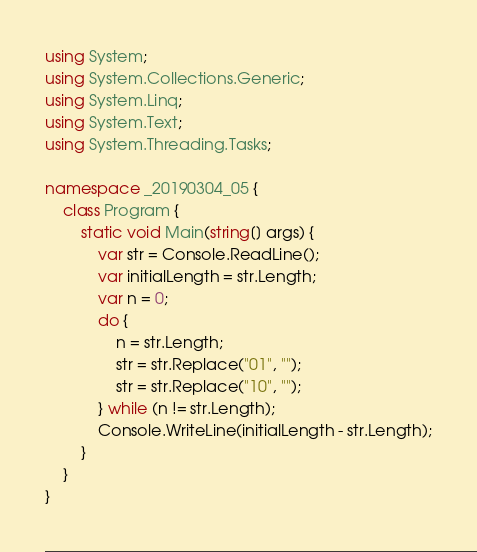Convert code to text. <code><loc_0><loc_0><loc_500><loc_500><_C#_>using System;
using System.Collections.Generic;
using System.Linq;
using System.Text;
using System.Threading.Tasks;

namespace _20190304_05 {
    class Program {
        static void Main(string[] args) {
            var str = Console.ReadLine();
            var initialLength = str.Length;
            var n = 0;
            do {
                n = str.Length;
                str = str.Replace("01", "");
                str = str.Replace("10", "");
            } while (n != str.Length);
            Console.WriteLine(initialLength - str.Length);
        }
    }
}
</code> 